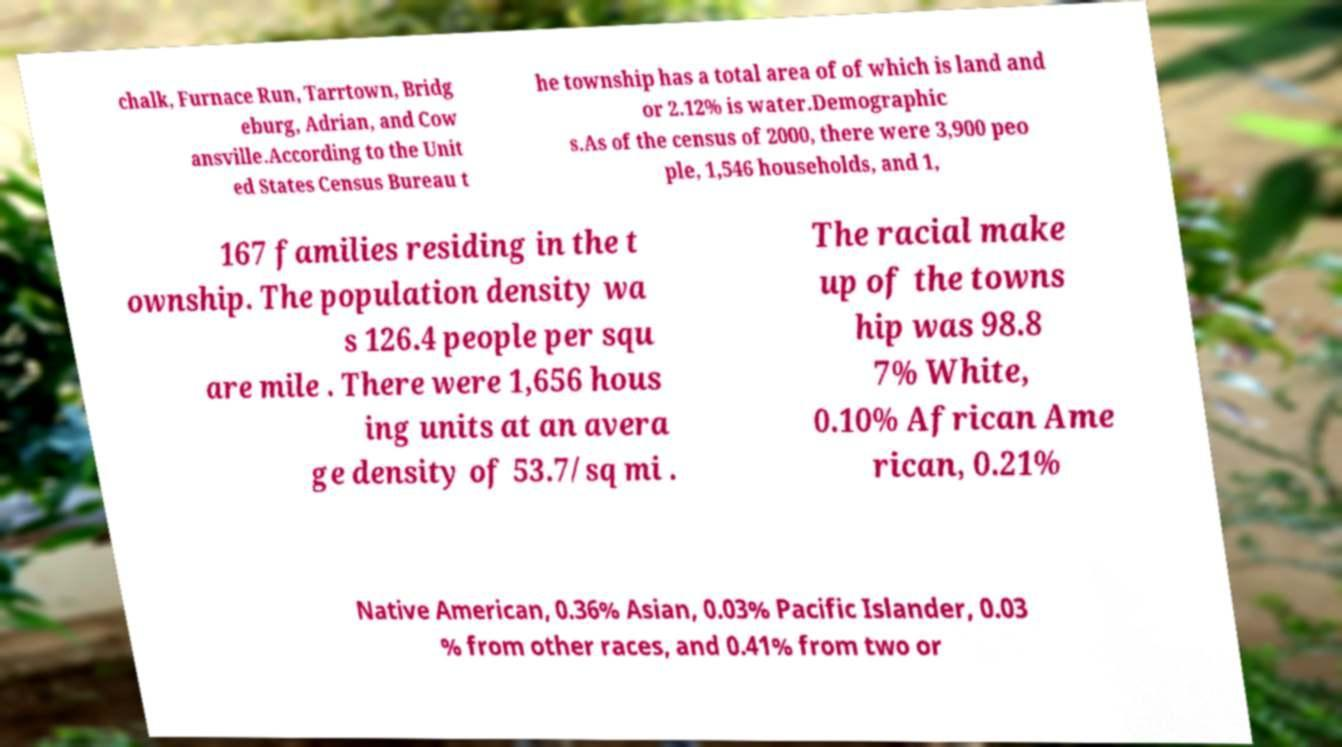Can you read and provide the text displayed in the image?This photo seems to have some interesting text. Can you extract and type it out for me? chalk, Furnace Run, Tarrtown, Bridg eburg, Adrian, and Cow ansville.According to the Unit ed States Census Bureau t he township has a total area of of which is land and or 2.12% is water.Demographic s.As of the census of 2000, there were 3,900 peo ple, 1,546 households, and 1, 167 families residing in the t ownship. The population density wa s 126.4 people per squ are mile . There were 1,656 hous ing units at an avera ge density of 53.7/sq mi . The racial make up of the towns hip was 98.8 7% White, 0.10% African Ame rican, 0.21% Native American, 0.36% Asian, 0.03% Pacific Islander, 0.03 % from other races, and 0.41% from two or 